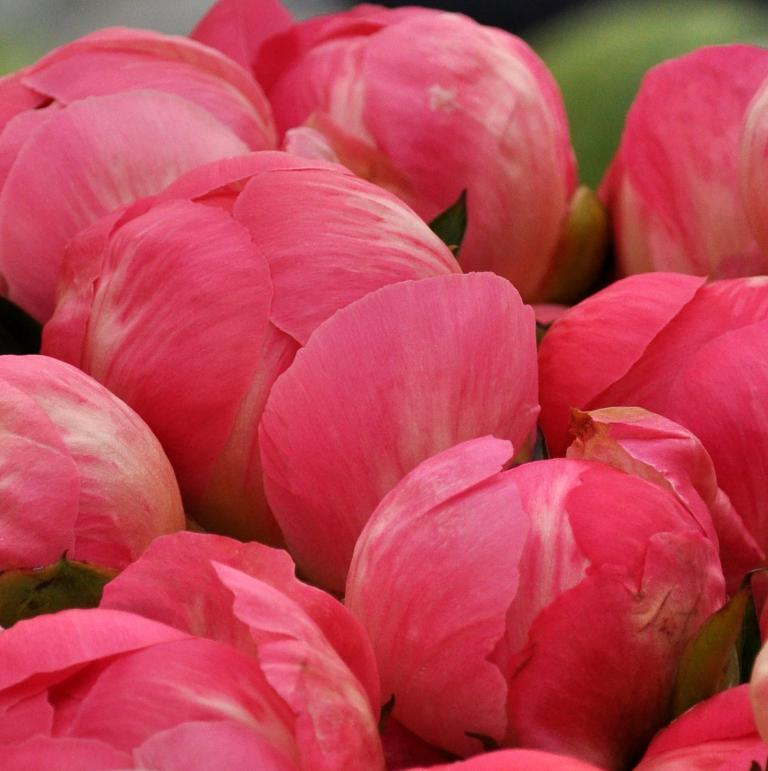What type of living organisms can be seen in the image? Flowers can be seen in the image. Can you describe the flowers in the image? Unfortunately, the facts provided do not give any specific details about the flowers. What might be the purpose of the flowers in the image? The purpose of the flowers in the image cannot be determined from the provided facts. What type of vacation is the governor planning based on the flowers in the image? There is no information about a governor or a vacation in the image, and the flowers cannot be used to infer any plans or intentions. 